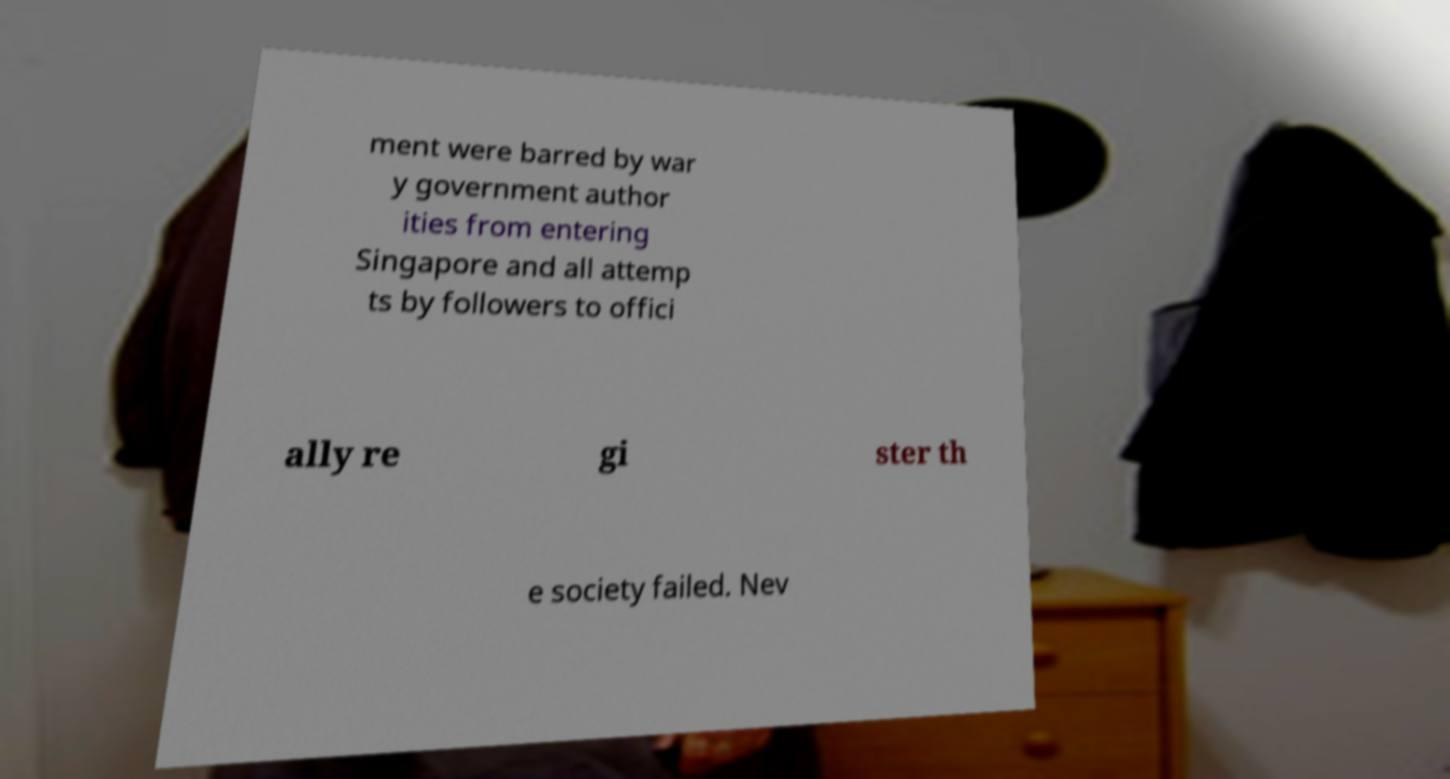Can you accurately transcribe the text from the provided image for me? ment were barred by war y government author ities from entering Singapore and all attemp ts by followers to offici ally re gi ster th e society failed. Nev 